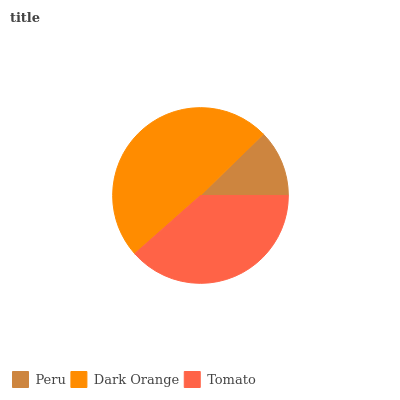Is Peru the minimum?
Answer yes or no. Yes. Is Dark Orange the maximum?
Answer yes or no. Yes. Is Tomato the minimum?
Answer yes or no. No. Is Tomato the maximum?
Answer yes or no. No. Is Dark Orange greater than Tomato?
Answer yes or no. Yes. Is Tomato less than Dark Orange?
Answer yes or no. Yes. Is Tomato greater than Dark Orange?
Answer yes or no. No. Is Dark Orange less than Tomato?
Answer yes or no. No. Is Tomato the high median?
Answer yes or no. Yes. Is Tomato the low median?
Answer yes or no. Yes. Is Dark Orange the high median?
Answer yes or no. No. Is Peru the low median?
Answer yes or no. No. 